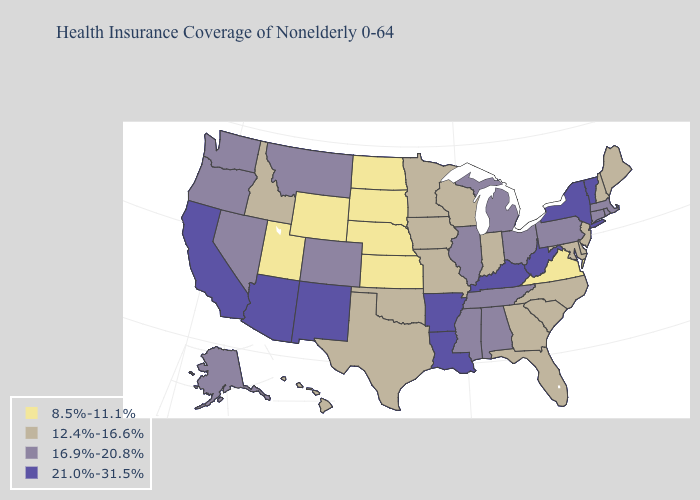What is the value of New Jersey?
Write a very short answer. 12.4%-16.6%. What is the value of Maine?
Be succinct. 12.4%-16.6%. Among the states that border Tennessee , does Mississippi have the highest value?
Keep it brief. No. What is the value of Hawaii?
Answer briefly. 12.4%-16.6%. What is the highest value in states that border Indiana?
Be succinct. 21.0%-31.5%. What is the lowest value in states that border Iowa?
Concise answer only. 8.5%-11.1%. What is the value of Tennessee?
Concise answer only. 16.9%-20.8%. What is the value of Washington?
Keep it brief. 16.9%-20.8%. Does the first symbol in the legend represent the smallest category?
Concise answer only. Yes. What is the lowest value in the USA?
Write a very short answer. 8.5%-11.1%. What is the value of Georgia?
Keep it brief. 12.4%-16.6%. Does Louisiana have the same value as Oklahoma?
Give a very brief answer. No. What is the highest value in states that border New Jersey?
Concise answer only. 21.0%-31.5%. 